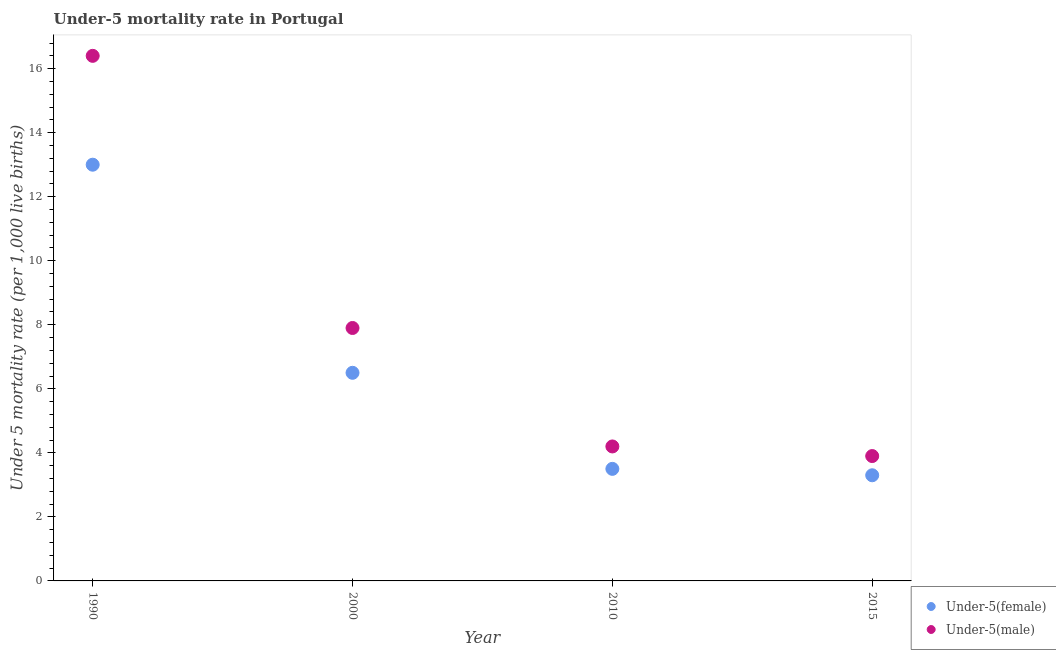How many different coloured dotlines are there?
Your answer should be very brief. 2. Is the number of dotlines equal to the number of legend labels?
Offer a very short reply. Yes. Across all years, what is the maximum under-5 male mortality rate?
Provide a short and direct response. 16.4. Across all years, what is the minimum under-5 female mortality rate?
Make the answer very short. 3.3. In which year was the under-5 male mortality rate maximum?
Offer a very short reply. 1990. In which year was the under-5 female mortality rate minimum?
Offer a very short reply. 2015. What is the total under-5 male mortality rate in the graph?
Provide a succinct answer. 32.4. What is the difference between the under-5 female mortality rate in 1990 and that in 2000?
Provide a short and direct response. 6.5. What is the average under-5 male mortality rate per year?
Keep it short and to the point. 8.1. In the year 2015, what is the difference between the under-5 female mortality rate and under-5 male mortality rate?
Give a very brief answer. -0.6. In how many years, is the under-5 male mortality rate greater than 0.8?
Your answer should be compact. 4. What is the ratio of the under-5 male mortality rate in 2010 to that in 2015?
Your response must be concise. 1.08. Is the under-5 female mortality rate in 2000 less than that in 2015?
Ensure brevity in your answer.  No. What is the difference between the highest and the second highest under-5 male mortality rate?
Your response must be concise. 8.5. In how many years, is the under-5 female mortality rate greater than the average under-5 female mortality rate taken over all years?
Provide a succinct answer. 1. Is the sum of the under-5 female mortality rate in 2010 and 2015 greater than the maximum under-5 male mortality rate across all years?
Your answer should be very brief. No. Does the under-5 female mortality rate monotonically increase over the years?
Your answer should be very brief. No. How many dotlines are there?
Keep it short and to the point. 2. How many years are there in the graph?
Provide a short and direct response. 4. What is the difference between two consecutive major ticks on the Y-axis?
Provide a short and direct response. 2. Does the graph contain any zero values?
Your answer should be very brief. No. Where does the legend appear in the graph?
Offer a terse response. Bottom right. How many legend labels are there?
Offer a terse response. 2. What is the title of the graph?
Make the answer very short. Under-5 mortality rate in Portugal. Does "Underweight" appear as one of the legend labels in the graph?
Give a very brief answer. No. What is the label or title of the Y-axis?
Your answer should be compact. Under 5 mortality rate (per 1,0 live births). What is the Under 5 mortality rate (per 1,000 live births) of Under-5(female) in 1990?
Offer a terse response. 13. What is the Under 5 mortality rate (per 1,000 live births) of Under-5(male) in 1990?
Give a very brief answer. 16.4. What is the Under 5 mortality rate (per 1,000 live births) in Under-5(male) in 2000?
Offer a terse response. 7.9. What is the Under 5 mortality rate (per 1,000 live births) in Under-5(male) in 2010?
Keep it short and to the point. 4.2. Across all years, what is the maximum Under 5 mortality rate (per 1,000 live births) of Under-5(female)?
Provide a succinct answer. 13. Across all years, what is the minimum Under 5 mortality rate (per 1,000 live births) of Under-5(male)?
Ensure brevity in your answer.  3.9. What is the total Under 5 mortality rate (per 1,000 live births) in Under-5(female) in the graph?
Provide a succinct answer. 26.3. What is the total Under 5 mortality rate (per 1,000 live births) of Under-5(male) in the graph?
Ensure brevity in your answer.  32.4. What is the difference between the Under 5 mortality rate (per 1,000 live births) of Under-5(female) in 1990 and that in 2000?
Offer a terse response. 6.5. What is the difference between the Under 5 mortality rate (per 1,000 live births) of Under-5(male) in 1990 and that in 2000?
Your answer should be compact. 8.5. What is the difference between the Under 5 mortality rate (per 1,000 live births) in Under-5(female) in 1990 and that in 2015?
Give a very brief answer. 9.7. What is the difference between the Under 5 mortality rate (per 1,000 live births) of Under-5(male) in 1990 and that in 2015?
Offer a very short reply. 12.5. What is the difference between the Under 5 mortality rate (per 1,000 live births) of Under-5(female) in 2000 and that in 2015?
Keep it short and to the point. 3.2. What is the difference between the Under 5 mortality rate (per 1,000 live births) in Under-5(male) in 2000 and that in 2015?
Make the answer very short. 4. What is the difference between the Under 5 mortality rate (per 1,000 live births) of Under-5(female) in 1990 and the Under 5 mortality rate (per 1,000 live births) of Under-5(male) in 2015?
Your answer should be very brief. 9.1. What is the difference between the Under 5 mortality rate (per 1,000 live births) in Under-5(female) in 2000 and the Under 5 mortality rate (per 1,000 live births) in Under-5(male) in 2015?
Provide a succinct answer. 2.6. What is the difference between the Under 5 mortality rate (per 1,000 live births) of Under-5(female) in 2010 and the Under 5 mortality rate (per 1,000 live births) of Under-5(male) in 2015?
Your answer should be very brief. -0.4. What is the average Under 5 mortality rate (per 1,000 live births) in Under-5(female) per year?
Offer a terse response. 6.58. In the year 2010, what is the difference between the Under 5 mortality rate (per 1,000 live births) of Under-5(female) and Under 5 mortality rate (per 1,000 live births) of Under-5(male)?
Provide a succinct answer. -0.7. What is the ratio of the Under 5 mortality rate (per 1,000 live births) in Under-5(male) in 1990 to that in 2000?
Your response must be concise. 2.08. What is the ratio of the Under 5 mortality rate (per 1,000 live births) of Under-5(female) in 1990 to that in 2010?
Your answer should be very brief. 3.71. What is the ratio of the Under 5 mortality rate (per 1,000 live births) in Under-5(male) in 1990 to that in 2010?
Your answer should be compact. 3.9. What is the ratio of the Under 5 mortality rate (per 1,000 live births) in Under-5(female) in 1990 to that in 2015?
Keep it short and to the point. 3.94. What is the ratio of the Under 5 mortality rate (per 1,000 live births) in Under-5(male) in 1990 to that in 2015?
Provide a succinct answer. 4.21. What is the ratio of the Under 5 mortality rate (per 1,000 live births) of Under-5(female) in 2000 to that in 2010?
Make the answer very short. 1.86. What is the ratio of the Under 5 mortality rate (per 1,000 live births) in Under-5(male) in 2000 to that in 2010?
Give a very brief answer. 1.88. What is the ratio of the Under 5 mortality rate (per 1,000 live births) in Under-5(female) in 2000 to that in 2015?
Your answer should be very brief. 1.97. What is the ratio of the Under 5 mortality rate (per 1,000 live births) of Under-5(male) in 2000 to that in 2015?
Ensure brevity in your answer.  2.03. What is the ratio of the Under 5 mortality rate (per 1,000 live births) of Under-5(female) in 2010 to that in 2015?
Offer a terse response. 1.06. What is the difference between the highest and the second highest Under 5 mortality rate (per 1,000 live births) in Under-5(female)?
Your answer should be very brief. 6.5. What is the difference between the highest and the second highest Under 5 mortality rate (per 1,000 live births) in Under-5(male)?
Make the answer very short. 8.5. What is the difference between the highest and the lowest Under 5 mortality rate (per 1,000 live births) in Under-5(female)?
Keep it short and to the point. 9.7. What is the difference between the highest and the lowest Under 5 mortality rate (per 1,000 live births) of Under-5(male)?
Make the answer very short. 12.5. 